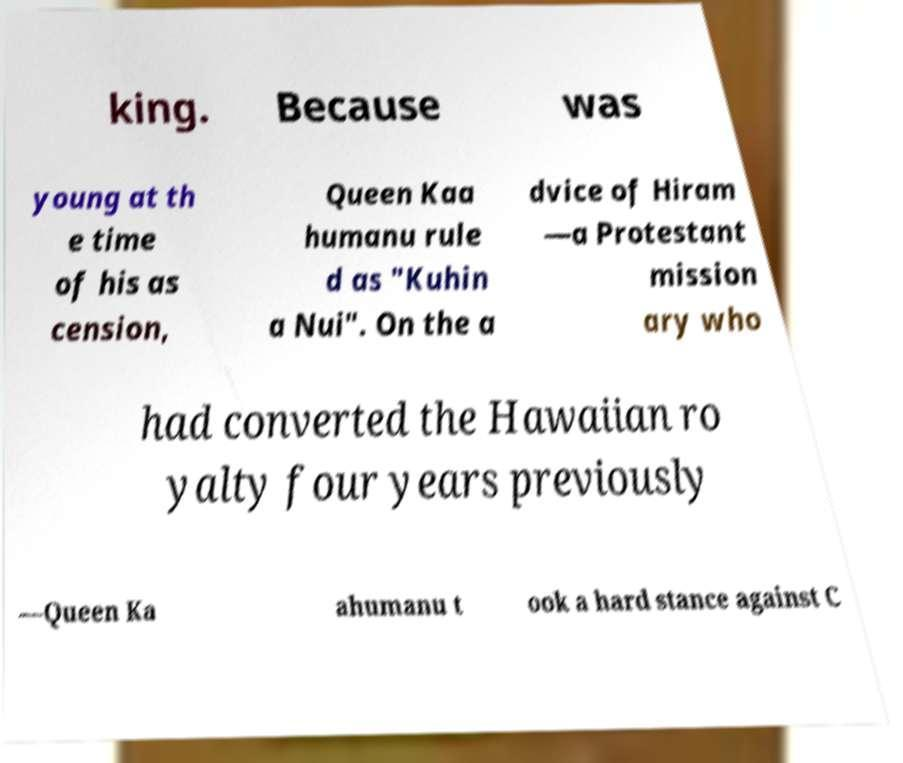Could you assist in decoding the text presented in this image and type it out clearly? king. Because was young at th e time of his as cension, Queen Kaa humanu rule d as "Kuhin a Nui". On the a dvice of Hiram —a Protestant mission ary who had converted the Hawaiian ro yalty four years previously —Queen Ka ahumanu t ook a hard stance against C 